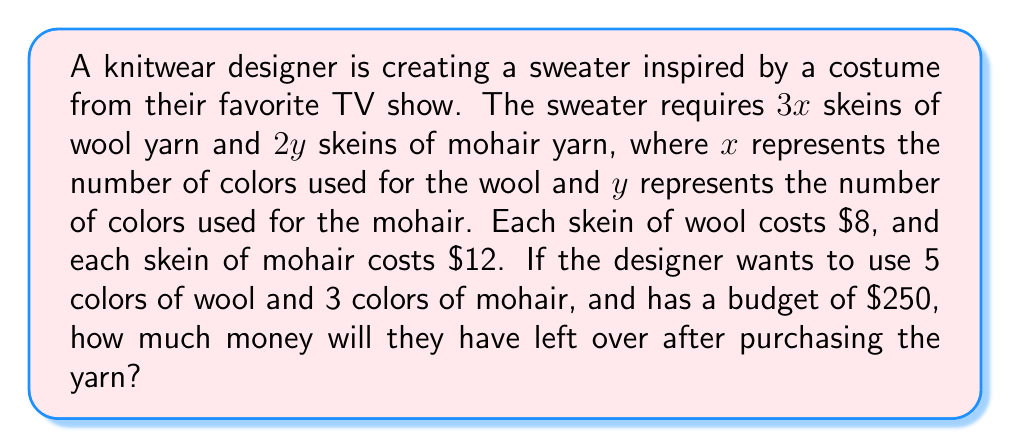Solve this math problem. Let's approach this step-by-step:

1) First, let's define our variables:
   $x = 5$ (number of wool colors)
   $y = 3$ (number of mohair colors)

2) Now, let's calculate the number of skeins needed:
   Wool skeins: $3x = 3(5) = 15$ skeins
   Mohair skeins: $2y = 2(3) = 6$ skeins

3) Next, let's calculate the cost for each type of yarn:
   Wool cost: $15 \times \$8 = \$120$
   Mohair cost: $6 \times \$12 = \$72$

4) Total cost of yarn:
   $\$120 + \$72 = \$192$

5) The designer's budget is $\$250$, so to find the money left over:
   $\$250 - \$192 = \$58$

Therefore, the designer will have $\$58$ left over after purchasing the yarn.
Answer: $\$58$ 